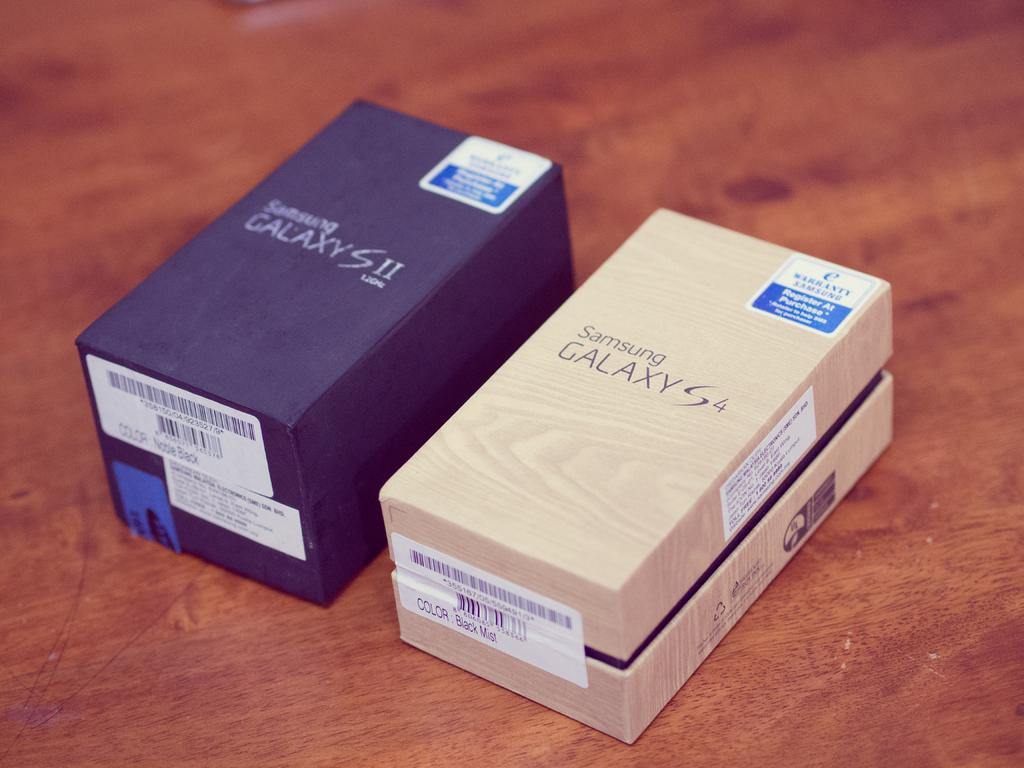<image>
Write a terse but informative summary of the picture. two phone boxes next to one another with both of them saying 'galaxy' on them 